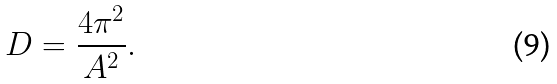Convert formula to latex. <formula><loc_0><loc_0><loc_500><loc_500>D = \frac { 4 \pi ^ { 2 } } { A ^ { 2 } } .</formula> 